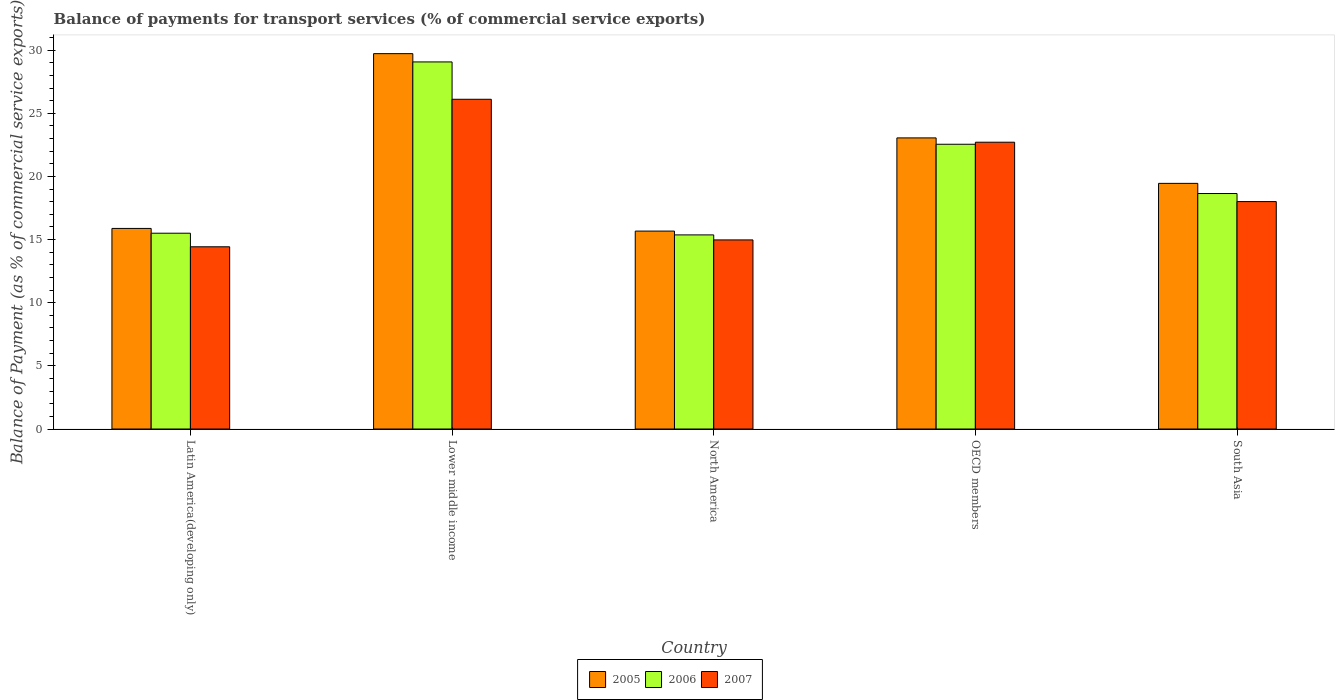How many different coloured bars are there?
Keep it short and to the point. 3. How many bars are there on the 5th tick from the left?
Your answer should be compact. 3. What is the label of the 3rd group of bars from the left?
Your answer should be compact. North America. What is the balance of payments for transport services in 2006 in OECD members?
Keep it short and to the point. 22.55. Across all countries, what is the maximum balance of payments for transport services in 2005?
Offer a very short reply. 29.72. Across all countries, what is the minimum balance of payments for transport services in 2007?
Ensure brevity in your answer.  14.43. In which country was the balance of payments for transport services in 2006 maximum?
Your response must be concise. Lower middle income. What is the total balance of payments for transport services in 2005 in the graph?
Offer a terse response. 103.79. What is the difference between the balance of payments for transport services in 2005 in Lower middle income and that in North America?
Offer a very short reply. 14.05. What is the difference between the balance of payments for transport services in 2007 in North America and the balance of payments for transport services in 2005 in Latin America(developing only)?
Provide a short and direct response. -0.91. What is the average balance of payments for transport services in 2005 per country?
Keep it short and to the point. 20.76. What is the difference between the balance of payments for transport services of/in 2006 and balance of payments for transport services of/in 2007 in Latin America(developing only)?
Provide a short and direct response. 1.07. In how many countries, is the balance of payments for transport services in 2005 greater than 18 %?
Ensure brevity in your answer.  3. What is the ratio of the balance of payments for transport services in 2007 in Lower middle income to that in South Asia?
Ensure brevity in your answer.  1.45. Is the difference between the balance of payments for transport services in 2006 in Latin America(developing only) and North America greater than the difference between the balance of payments for transport services in 2007 in Latin America(developing only) and North America?
Your answer should be very brief. Yes. What is the difference between the highest and the second highest balance of payments for transport services in 2007?
Your answer should be compact. 8.1. What is the difference between the highest and the lowest balance of payments for transport services in 2007?
Provide a succinct answer. 11.68. In how many countries, is the balance of payments for transport services in 2006 greater than the average balance of payments for transport services in 2006 taken over all countries?
Your response must be concise. 2. What does the 3rd bar from the left in North America represents?
Your response must be concise. 2007. Is it the case that in every country, the sum of the balance of payments for transport services in 2005 and balance of payments for transport services in 2007 is greater than the balance of payments for transport services in 2006?
Offer a terse response. Yes. How many bars are there?
Offer a very short reply. 15. How many countries are there in the graph?
Offer a very short reply. 5. Does the graph contain any zero values?
Provide a short and direct response. No. Does the graph contain grids?
Provide a succinct answer. No. How many legend labels are there?
Make the answer very short. 3. How are the legend labels stacked?
Your response must be concise. Horizontal. What is the title of the graph?
Your answer should be very brief. Balance of payments for transport services (% of commercial service exports). What is the label or title of the X-axis?
Provide a short and direct response. Country. What is the label or title of the Y-axis?
Provide a succinct answer. Balance of Payment (as % of commercial service exports). What is the Balance of Payment (as % of commercial service exports) in 2005 in Latin America(developing only)?
Your answer should be compact. 15.88. What is the Balance of Payment (as % of commercial service exports) in 2006 in Latin America(developing only)?
Offer a very short reply. 15.5. What is the Balance of Payment (as % of commercial service exports) in 2007 in Latin America(developing only)?
Your answer should be very brief. 14.43. What is the Balance of Payment (as % of commercial service exports) in 2005 in Lower middle income?
Ensure brevity in your answer.  29.72. What is the Balance of Payment (as % of commercial service exports) in 2006 in Lower middle income?
Your response must be concise. 29.07. What is the Balance of Payment (as % of commercial service exports) in 2007 in Lower middle income?
Provide a short and direct response. 26.11. What is the Balance of Payment (as % of commercial service exports) of 2005 in North America?
Offer a terse response. 15.67. What is the Balance of Payment (as % of commercial service exports) of 2006 in North America?
Your response must be concise. 15.37. What is the Balance of Payment (as % of commercial service exports) of 2007 in North America?
Keep it short and to the point. 14.97. What is the Balance of Payment (as % of commercial service exports) in 2005 in OECD members?
Offer a very short reply. 23.05. What is the Balance of Payment (as % of commercial service exports) of 2006 in OECD members?
Your response must be concise. 22.55. What is the Balance of Payment (as % of commercial service exports) in 2007 in OECD members?
Keep it short and to the point. 22.71. What is the Balance of Payment (as % of commercial service exports) in 2005 in South Asia?
Offer a very short reply. 19.45. What is the Balance of Payment (as % of commercial service exports) of 2006 in South Asia?
Your response must be concise. 18.65. What is the Balance of Payment (as % of commercial service exports) in 2007 in South Asia?
Your response must be concise. 18.01. Across all countries, what is the maximum Balance of Payment (as % of commercial service exports) in 2005?
Keep it short and to the point. 29.72. Across all countries, what is the maximum Balance of Payment (as % of commercial service exports) in 2006?
Provide a succinct answer. 29.07. Across all countries, what is the maximum Balance of Payment (as % of commercial service exports) in 2007?
Offer a very short reply. 26.11. Across all countries, what is the minimum Balance of Payment (as % of commercial service exports) of 2005?
Offer a very short reply. 15.67. Across all countries, what is the minimum Balance of Payment (as % of commercial service exports) of 2006?
Your answer should be very brief. 15.37. Across all countries, what is the minimum Balance of Payment (as % of commercial service exports) of 2007?
Give a very brief answer. 14.43. What is the total Balance of Payment (as % of commercial service exports) in 2005 in the graph?
Ensure brevity in your answer.  103.79. What is the total Balance of Payment (as % of commercial service exports) of 2006 in the graph?
Offer a very short reply. 101.14. What is the total Balance of Payment (as % of commercial service exports) of 2007 in the graph?
Your response must be concise. 96.24. What is the difference between the Balance of Payment (as % of commercial service exports) in 2005 in Latin America(developing only) and that in Lower middle income?
Provide a succinct answer. -13.84. What is the difference between the Balance of Payment (as % of commercial service exports) of 2006 in Latin America(developing only) and that in Lower middle income?
Give a very brief answer. -13.56. What is the difference between the Balance of Payment (as % of commercial service exports) of 2007 in Latin America(developing only) and that in Lower middle income?
Offer a terse response. -11.68. What is the difference between the Balance of Payment (as % of commercial service exports) of 2005 in Latin America(developing only) and that in North America?
Offer a terse response. 0.21. What is the difference between the Balance of Payment (as % of commercial service exports) in 2006 in Latin America(developing only) and that in North America?
Provide a succinct answer. 0.13. What is the difference between the Balance of Payment (as % of commercial service exports) in 2007 in Latin America(developing only) and that in North America?
Provide a succinct answer. -0.54. What is the difference between the Balance of Payment (as % of commercial service exports) in 2005 in Latin America(developing only) and that in OECD members?
Make the answer very short. -7.17. What is the difference between the Balance of Payment (as % of commercial service exports) in 2006 in Latin America(developing only) and that in OECD members?
Give a very brief answer. -7.04. What is the difference between the Balance of Payment (as % of commercial service exports) of 2007 in Latin America(developing only) and that in OECD members?
Give a very brief answer. -8.28. What is the difference between the Balance of Payment (as % of commercial service exports) in 2005 in Latin America(developing only) and that in South Asia?
Provide a succinct answer. -3.57. What is the difference between the Balance of Payment (as % of commercial service exports) in 2006 in Latin America(developing only) and that in South Asia?
Provide a succinct answer. -3.14. What is the difference between the Balance of Payment (as % of commercial service exports) of 2007 in Latin America(developing only) and that in South Asia?
Offer a terse response. -3.58. What is the difference between the Balance of Payment (as % of commercial service exports) in 2005 in Lower middle income and that in North America?
Your answer should be very brief. 14.05. What is the difference between the Balance of Payment (as % of commercial service exports) in 2006 in Lower middle income and that in North America?
Provide a short and direct response. 13.7. What is the difference between the Balance of Payment (as % of commercial service exports) of 2007 in Lower middle income and that in North America?
Give a very brief answer. 11.14. What is the difference between the Balance of Payment (as % of commercial service exports) in 2005 in Lower middle income and that in OECD members?
Provide a short and direct response. 6.67. What is the difference between the Balance of Payment (as % of commercial service exports) of 2006 in Lower middle income and that in OECD members?
Give a very brief answer. 6.52. What is the difference between the Balance of Payment (as % of commercial service exports) in 2007 in Lower middle income and that in OECD members?
Offer a very short reply. 3.4. What is the difference between the Balance of Payment (as % of commercial service exports) in 2005 in Lower middle income and that in South Asia?
Give a very brief answer. 10.27. What is the difference between the Balance of Payment (as % of commercial service exports) of 2006 in Lower middle income and that in South Asia?
Make the answer very short. 10.42. What is the difference between the Balance of Payment (as % of commercial service exports) in 2007 in Lower middle income and that in South Asia?
Provide a succinct answer. 8.1. What is the difference between the Balance of Payment (as % of commercial service exports) in 2005 in North America and that in OECD members?
Your answer should be compact. -7.38. What is the difference between the Balance of Payment (as % of commercial service exports) in 2006 in North America and that in OECD members?
Provide a succinct answer. -7.18. What is the difference between the Balance of Payment (as % of commercial service exports) of 2007 in North America and that in OECD members?
Offer a very short reply. -7.74. What is the difference between the Balance of Payment (as % of commercial service exports) of 2005 in North America and that in South Asia?
Provide a succinct answer. -3.78. What is the difference between the Balance of Payment (as % of commercial service exports) of 2006 in North America and that in South Asia?
Ensure brevity in your answer.  -3.28. What is the difference between the Balance of Payment (as % of commercial service exports) in 2007 in North America and that in South Asia?
Provide a succinct answer. -3.03. What is the difference between the Balance of Payment (as % of commercial service exports) in 2005 in OECD members and that in South Asia?
Your response must be concise. 3.6. What is the difference between the Balance of Payment (as % of commercial service exports) in 2006 in OECD members and that in South Asia?
Make the answer very short. 3.9. What is the difference between the Balance of Payment (as % of commercial service exports) in 2007 in OECD members and that in South Asia?
Offer a terse response. 4.7. What is the difference between the Balance of Payment (as % of commercial service exports) in 2005 in Latin America(developing only) and the Balance of Payment (as % of commercial service exports) in 2006 in Lower middle income?
Your answer should be compact. -13.19. What is the difference between the Balance of Payment (as % of commercial service exports) of 2005 in Latin America(developing only) and the Balance of Payment (as % of commercial service exports) of 2007 in Lower middle income?
Keep it short and to the point. -10.23. What is the difference between the Balance of Payment (as % of commercial service exports) in 2006 in Latin America(developing only) and the Balance of Payment (as % of commercial service exports) in 2007 in Lower middle income?
Give a very brief answer. -10.61. What is the difference between the Balance of Payment (as % of commercial service exports) of 2005 in Latin America(developing only) and the Balance of Payment (as % of commercial service exports) of 2006 in North America?
Keep it short and to the point. 0.51. What is the difference between the Balance of Payment (as % of commercial service exports) in 2005 in Latin America(developing only) and the Balance of Payment (as % of commercial service exports) in 2007 in North America?
Your answer should be compact. 0.91. What is the difference between the Balance of Payment (as % of commercial service exports) in 2006 in Latin America(developing only) and the Balance of Payment (as % of commercial service exports) in 2007 in North America?
Your answer should be compact. 0.53. What is the difference between the Balance of Payment (as % of commercial service exports) of 2005 in Latin America(developing only) and the Balance of Payment (as % of commercial service exports) of 2006 in OECD members?
Offer a very short reply. -6.67. What is the difference between the Balance of Payment (as % of commercial service exports) in 2005 in Latin America(developing only) and the Balance of Payment (as % of commercial service exports) in 2007 in OECD members?
Give a very brief answer. -6.83. What is the difference between the Balance of Payment (as % of commercial service exports) of 2006 in Latin America(developing only) and the Balance of Payment (as % of commercial service exports) of 2007 in OECD members?
Make the answer very short. -7.21. What is the difference between the Balance of Payment (as % of commercial service exports) in 2005 in Latin America(developing only) and the Balance of Payment (as % of commercial service exports) in 2006 in South Asia?
Offer a very short reply. -2.76. What is the difference between the Balance of Payment (as % of commercial service exports) in 2005 in Latin America(developing only) and the Balance of Payment (as % of commercial service exports) in 2007 in South Asia?
Your answer should be very brief. -2.13. What is the difference between the Balance of Payment (as % of commercial service exports) of 2006 in Latin America(developing only) and the Balance of Payment (as % of commercial service exports) of 2007 in South Asia?
Make the answer very short. -2.5. What is the difference between the Balance of Payment (as % of commercial service exports) in 2005 in Lower middle income and the Balance of Payment (as % of commercial service exports) in 2006 in North America?
Provide a short and direct response. 14.35. What is the difference between the Balance of Payment (as % of commercial service exports) of 2005 in Lower middle income and the Balance of Payment (as % of commercial service exports) of 2007 in North America?
Make the answer very short. 14.75. What is the difference between the Balance of Payment (as % of commercial service exports) in 2006 in Lower middle income and the Balance of Payment (as % of commercial service exports) in 2007 in North America?
Your response must be concise. 14.09. What is the difference between the Balance of Payment (as % of commercial service exports) of 2005 in Lower middle income and the Balance of Payment (as % of commercial service exports) of 2006 in OECD members?
Provide a succinct answer. 7.17. What is the difference between the Balance of Payment (as % of commercial service exports) in 2005 in Lower middle income and the Balance of Payment (as % of commercial service exports) in 2007 in OECD members?
Keep it short and to the point. 7.01. What is the difference between the Balance of Payment (as % of commercial service exports) of 2006 in Lower middle income and the Balance of Payment (as % of commercial service exports) of 2007 in OECD members?
Give a very brief answer. 6.36. What is the difference between the Balance of Payment (as % of commercial service exports) of 2005 in Lower middle income and the Balance of Payment (as % of commercial service exports) of 2006 in South Asia?
Ensure brevity in your answer.  11.08. What is the difference between the Balance of Payment (as % of commercial service exports) of 2005 in Lower middle income and the Balance of Payment (as % of commercial service exports) of 2007 in South Asia?
Your answer should be very brief. 11.72. What is the difference between the Balance of Payment (as % of commercial service exports) in 2006 in Lower middle income and the Balance of Payment (as % of commercial service exports) in 2007 in South Asia?
Give a very brief answer. 11.06. What is the difference between the Balance of Payment (as % of commercial service exports) of 2005 in North America and the Balance of Payment (as % of commercial service exports) of 2006 in OECD members?
Provide a short and direct response. -6.88. What is the difference between the Balance of Payment (as % of commercial service exports) in 2005 in North America and the Balance of Payment (as % of commercial service exports) in 2007 in OECD members?
Your answer should be very brief. -7.04. What is the difference between the Balance of Payment (as % of commercial service exports) in 2006 in North America and the Balance of Payment (as % of commercial service exports) in 2007 in OECD members?
Your answer should be compact. -7.34. What is the difference between the Balance of Payment (as % of commercial service exports) of 2005 in North America and the Balance of Payment (as % of commercial service exports) of 2006 in South Asia?
Offer a terse response. -2.98. What is the difference between the Balance of Payment (as % of commercial service exports) of 2005 in North America and the Balance of Payment (as % of commercial service exports) of 2007 in South Asia?
Your answer should be very brief. -2.34. What is the difference between the Balance of Payment (as % of commercial service exports) in 2006 in North America and the Balance of Payment (as % of commercial service exports) in 2007 in South Asia?
Offer a terse response. -2.64. What is the difference between the Balance of Payment (as % of commercial service exports) in 2005 in OECD members and the Balance of Payment (as % of commercial service exports) in 2006 in South Asia?
Provide a succinct answer. 4.4. What is the difference between the Balance of Payment (as % of commercial service exports) of 2005 in OECD members and the Balance of Payment (as % of commercial service exports) of 2007 in South Asia?
Your response must be concise. 5.04. What is the difference between the Balance of Payment (as % of commercial service exports) in 2006 in OECD members and the Balance of Payment (as % of commercial service exports) in 2007 in South Asia?
Your answer should be compact. 4.54. What is the average Balance of Payment (as % of commercial service exports) in 2005 per country?
Offer a very short reply. 20.76. What is the average Balance of Payment (as % of commercial service exports) of 2006 per country?
Provide a succinct answer. 20.23. What is the average Balance of Payment (as % of commercial service exports) of 2007 per country?
Your answer should be very brief. 19.25. What is the difference between the Balance of Payment (as % of commercial service exports) in 2005 and Balance of Payment (as % of commercial service exports) in 2006 in Latin America(developing only)?
Provide a succinct answer. 0.38. What is the difference between the Balance of Payment (as % of commercial service exports) of 2005 and Balance of Payment (as % of commercial service exports) of 2007 in Latin America(developing only)?
Offer a terse response. 1.45. What is the difference between the Balance of Payment (as % of commercial service exports) in 2006 and Balance of Payment (as % of commercial service exports) in 2007 in Latin America(developing only)?
Ensure brevity in your answer.  1.07. What is the difference between the Balance of Payment (as % of commercial service exports) in 2005 and Balance of Payment (as % of commercial service exports) in 2006 in Lower middle income?
Your answer should be very brief. 0.66. What is the difference between the Balance of Payment (as % of commercial service exports) in 2005 and Balance of Payment (as % of commercial service exports) in 2007 in Lower middle income?
Make the answer very short. 3.61. What is the difference between the Balance of Payment (as % of commercial service exports) of 2006 and Balance of Payment (as % of commercial service exports) of 2007 in Lower middle income?
Keep it short and to the point. 2.96. What is the difference between the Balance of Payment (as % of commercial service exports) of 2005 and Balance of Payment (as % of commercial service exports) of 2006 in North America?
Offer a very short reply. 0.3. What is the difference between the Balance of Payment (as % of commercial service exports) in 2005 and Balance of Payment (as % of commercial service exports) in 2007 in North America?
Your answer should be very brief. 0.7. What is the difference between the Balance of Payment (as % of commercial service exports) of 2006 and Balance of Payment (as % of commercial service exports) of 2007 in North America?
Your answer should be very brief. 0.4. What is the difference between the Balance of Payment (as % of commercial service exports) of 2005 and Balance of Payment (as % of commercial service exports) of 2006 in OECD members?
Provide a short and direct response. 0.5. What is the difference between the Balance of Payment (as % of commercial service exports) in 2005 and Balance of Payment (as % of commercial service exports) in 2007 in OECD members?
Your answer should be very brief. 0.34. What is the difference between the Balance of Payment (as % of commercial service exports) in 2006 and Balance of Payment (as % of commercial service exports) in 2007 in OECD members?
Offer a terse response. -0.16. What is the difference between the Balance of Payment (as % of commercial service exports) in 2005 and Balance of Payment (as % of commercial service exports) in 2006 in South Asia?
Your response must be concise. 0.8. What is the difference between the Balance of Payment (as % of commercial service exports) of 2005 and Balance of Payment (as % of commercial service exports) of 2007 in South Asia?
Provide a succinct answer. 1.44. What is the difference between the Balance of Payment (as % of commercial service exports) of 2006 and Balance of Payment (as % of commercial service exports) of 2007 in South Asia?
Provide a succinct answer. 0.64. What is the ratio of the Balance of Payment (as % of commercial service exports) of 2005 in Latin America(developing only) to that in Lower middle income?
Ensure brevity in your answer.  0.53. What is the ratio of the Balance of Payment (as % of commercial service exports) in 2006 in Latin America(developing only) to that in Lower middle income?
Offer a very short reply. 0.53. What is the ratio of the Balance of Payment (as % of commercial service exports) of 2007 in Latin America(developing only) to that in Lower middle income?
Provide a succinct answer. 0.55. What is the ratio of the Balance of Payment (as % of commercial service exports) of 2005 in Latin America(developing only) to that in North America?
Give a very brief answer. 1.01. What is the ratio of the Balance of Payment (as % of commercial service exports) of 2006 in Latin America(developing only) to that in North America?
Give a very brief answer. 1.01. What is the ratio of the Balance of Payment (as % of commercial service exports) of 2007 in Latin America(developing only) to that in North America?
Your answer should be compact. 0.96. What is the ratio of the Balance of Payment (as % of commercial service exports) of 2005 in Latin America(developing only) to that in OECD members?
Offer a very short reply. 0.69. What is the ratio of the Balance of Payment (as % of commercial service exports) of 2006 in Latin America(developing only) to that in OECD members?
Your answer should be compact. 0.69. What is the ratio of the Balance of Payment (as % of commercial service exports) of 2007 in Latin America(developing only) to that in OECD members?
Give a very brief answer. 0.64. What is the ratio of the Balance of Payment (as % of commercial service exports) in 2005 in Latin America(developing only) to that in South Asia?
Your answer should be compact. 0.82. What is the ratio of the Balance of Payment (as % of commercial service exports) in 2006 in Latin America(developing only) to that in South Asia?
Offer a terse response. 0.83. What is the ratio of the Balance of Payment (as % of commercial service exports) of 2007 in Latin America(developing only) to that in South Asia?
Your answer should be very brief. 0.8. What is the ratio of the Balance of Payment (as % of commercial service exports) in 2005 in Lower middle income to that in North America?
Your response must be concise. 1.9. What is the ratio of the Balance of Payment (as % of commercial service exports) of 2006 in Lower middle income to that in North America?
Your response must be concise. 1.89. What is the ratio of the Balance of Payment (as % of commercial service exports) in 2007 in Lower middle income to that in North America?
Keep it short and to the point. 1.74. What is the ratio of the Balance of Payment (as % of commercial service exports) in 2005 in Lower middle income to that in OECD members?
Offer a very short reply. 1.29. What is the ratio of the Balance of Payment (as % of commercial service exports) in 2006 in Lower middle income to that in OECD members?
Your answer should be compact. 1.29. What is the ratio of the Balance of Payment (as % of commercial service exports) in 2007 in Lower middle income to that in OECD members?
Make the answer very short. 1.15. What is the ratio of the Balance of Payment (as % of commercial service exports) of 2005 in Lower middle income to that in South Asia?
Provide a short and direct response. 1.53. What is the ratio of the Balance of Payment (as % of commercial service exports) in 2006 in Lower middle income to that in South Asia?
Your answer should be compact. 1.56. What is the ratio of the Balance of Payment (as % of commercial service exports) of 2007 in Lower middle income to that in South Asia?
Offer a very short reply. 1.45. What is the ratio of the Balance of Payment (as % of commercial service exports) in 2005 in North America to that in OECD members?
Give a very brief answer. 0.68. What is the ratio of the Balance of Payment (as % of commercial service exports) in 2006 in North America to that in OECD members?
Give a very brief answer. 0.68. What is the ratio of the Balance of Payment (as % of commercial service exports) in 2007 in North America to that in OECD members?
Your answer should be compact. 0.66. What is the ratio of the Balance of Payment (as % of commercial service exports) of 2005 in North America to that in South Asia?
Give a very brief answer. 0.81. What is the ratio of the Balance of Payment (as % of commercial service exports) in 2006 in North America to that in South Asia?
Ensure brevity in your answer.  0.82. What is the ratio of the Balance of Payment (as % of commercial service exports) in 2007 in North America to that in South Asia?
Ensure brevity in your answer.  0.83. What is the ratio of the Balance of Payment (as % of commercial service exports) of 2005 in OECD members to that in South Asia?
Your answer should be compact. 1.19. What is the ratio of the Balance of Payment (as % of commercial service exports) of 2006 in OECD members to that in South Asia?
Offer a very short reply. 1.21. What is the ratio of the Balance of Payment (as % of commercial service exports) of 2007 in OECD members to that in South Asia?
Your answer should be very brief. 1.26. What is the difference between the highest and the second highest Balance of Payment (as % of commercial service exports) of 2005?
Your answer should be very brief. 6.67. What is the difference between the highest and the second highest Balance of Payment (as % of commercial service exports) of 2006?
Ensure brevity in your answer.  6.52. What is the difference between the highest and the second highest Balance of Payment (as % of commercial service exports) in 2007?
Your answer should be very brief. 3.4. What is the difference between the highest and the lowest Balance of Payment (as % of commercial service exports) in 2005?
Offer a terse response. 14.05. What is the difference between the highest and the lowest Balance of Payment (as % of commercial service exports) in 2006?
Make the answer very short. 13.7. What is the difference between the highest and the lowest Balance of Payment (as % of commercial service exports) in 2007?
Your answer should be compact. 11.68. 